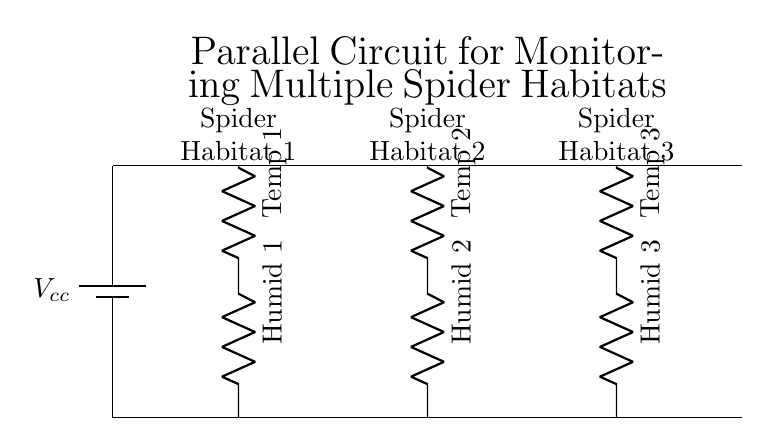What is the primary function of the resistors in this circuit? The resistors are temperature and humidity sensors for each spider habitat, measuring the respective conditions.
Answer: temperature and humidity sensors How many spider habitats are monitored in this circuit? There are three habitats shown, as indicated by the labels for each habitat in the circuit diagram.
Answer: three What happens to the voltage across each habitat's sensors? In a parallel circuit, the voltage across each branch (habitat) is the same as the source voltage, ensuring each sensor receives sufficient power.
Answer: same as source voltage Which component provides power to the circuit? The battery is the component specified as providing power, labeled as Vcc in the diagram.
Answer: battery How is the configuration of this circuit classified? This circuit is a parallel circuit because each habitat is connected independently to the same power supply, allowing for simultaneous measurement.
Answer: parallel circuit What do the labels "Temp 1", "Humid 1", etc., indicate? The labels indicate the type of sensor used in each habitat: temperature or humidity, associated with that specific habitat.
Answer: type of sensors 